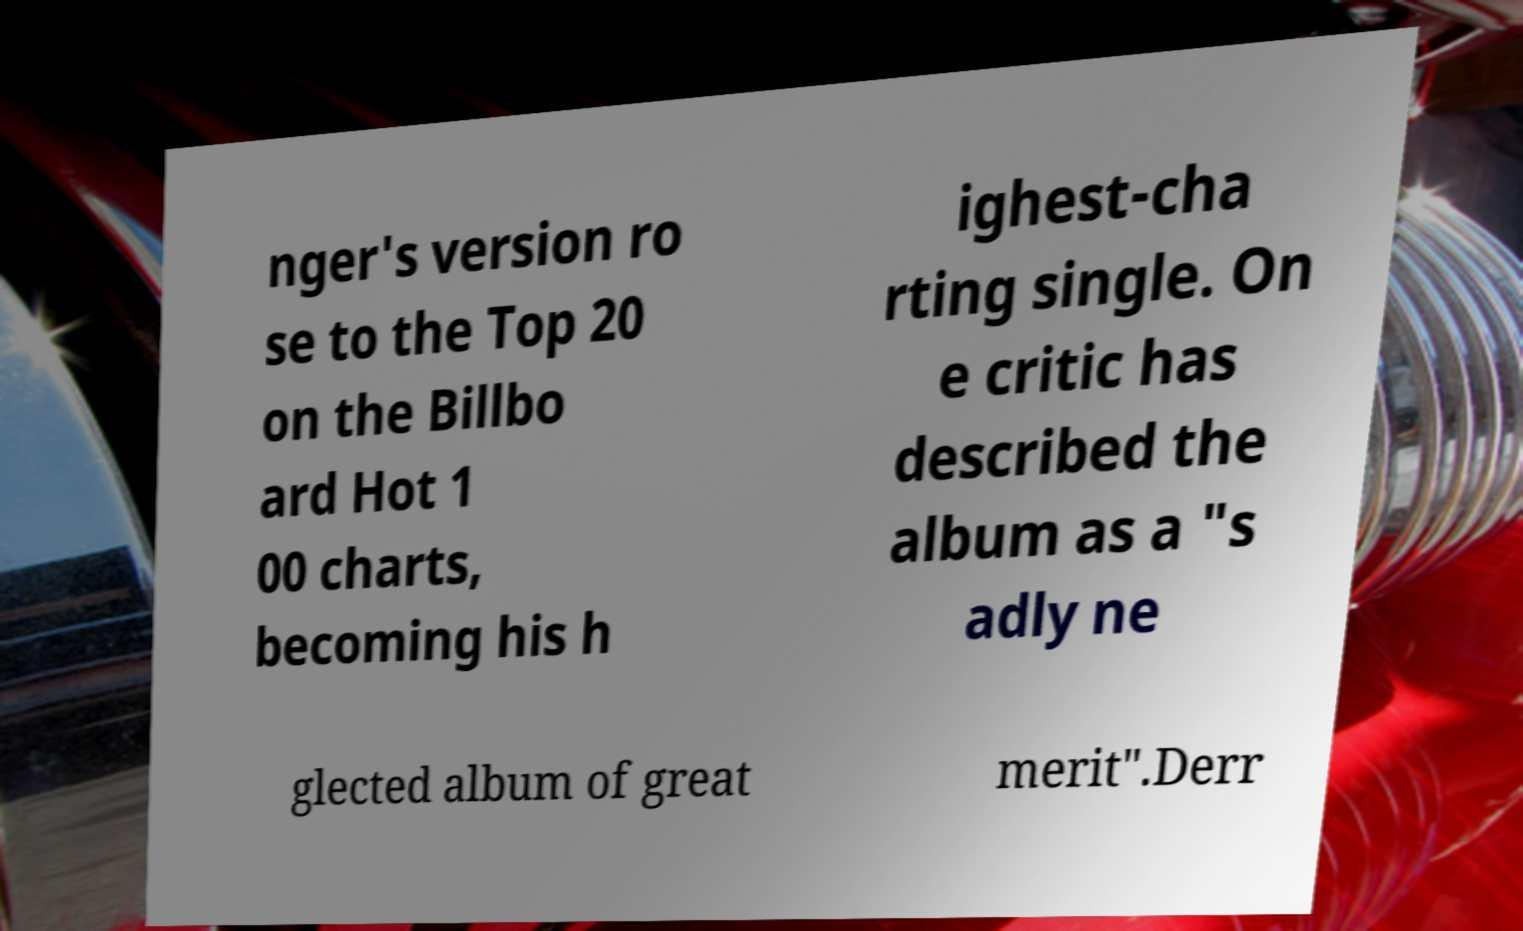Could you extract and type out the text from this image? nger's version ro se to the Top 20 on the Billbo ard Hot 1 00 charts, becoming his h ighest-cha rting single. On e critic has described the album as a "s adly ne glected album of great merit".Derr 